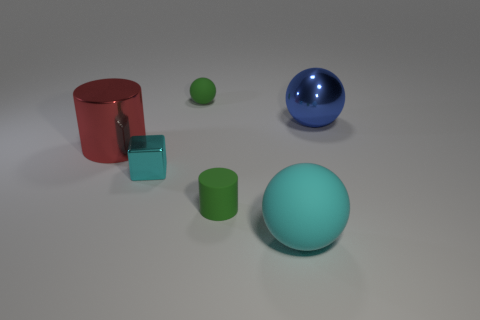What is the color of the other big object that is the same shape as the large blue metallic thing?
Provide a short and direct response. Cyan. What is the color of the other large sphere that is the same material as the green ball?
Make the answer very short. Cyan. Are there the same number of large balls left of the large matte sphere and small cyan things?
Your response must be concise. No. There is a matte ball that is in front of the blue ball; is it the same size as the tiny green matte ball?
Your answer should be compact. No. There is a matte sphere that is the same size as the matte cylinder; what color is it?
Your response must be concise. Green. Are there any cyan balls on the left side of the cyan object to the right of the tiny green matte thing that is behind the cyan shiny block?
Offer a terse response. No. There is a cyan object on the left side of the big cyan matte thing; what material is it?
Your answer should be very brief. Metal. Is the shape of the cyan metal object the same as the small object behind the tiny cyan cube?
Ensure brevity in your answer.  No. Are there an equal number of small cylinders in front of the large rubber sphere and small metal things in front of the tiny metallic object?
Give a very brief answer. Yes. What number of other things are there of the same material as the small cyan cube
Your response must be concise. 2. 